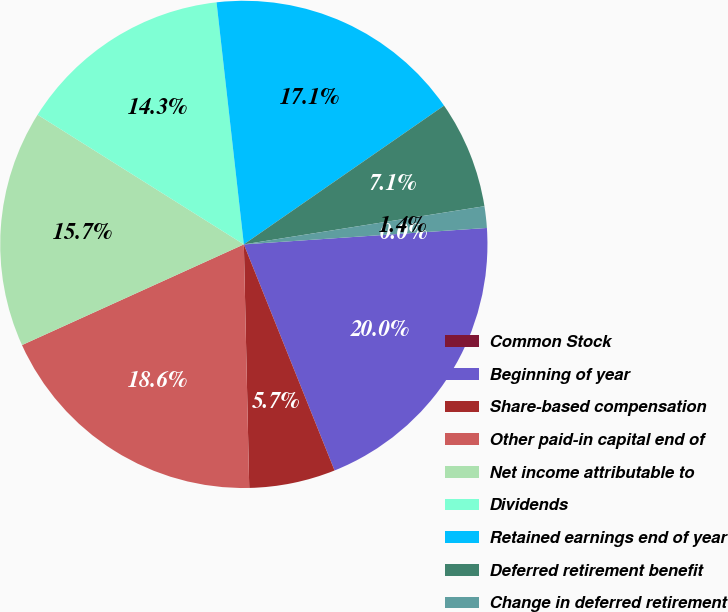Convert chart to OTSL. <chart><loc_0><loc_0><loc_500><loc_500><pie_chart><fcel>Common Stock<fcel>Beginning of year<fcel>Share-based compensation<fcel>Other paid-in capital end of<fcel>Net income attributable to<fcel>Dividends<fcel>Retained earnings end of year<fcel>Deferred retirement benefit<fcel>Change in deferred retirement<nl><fcel>0.0%<fcel>20.0%<fcel>5.72%<fcel>18.57%<fcel>15.71%<fcel>14.28%<fcel>17.14%<fcel>7.14%<fcel>1.43%<nl></chart> 